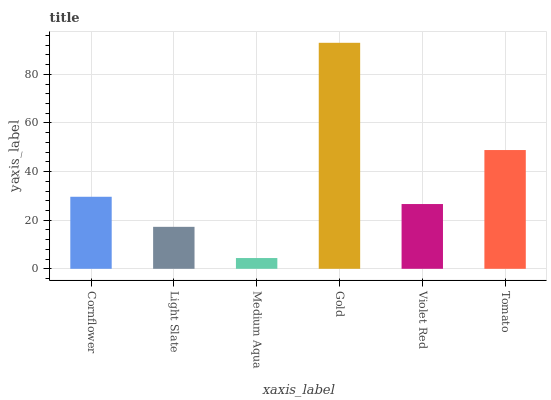Is Medium Aqua the minimum?
Answer yes or no. Yes. Is Gold the maximum?
Answer yes or no. Yes. Is Light Slate the minimum?
Answer yes or no. No. Is Light Slate the maximum?
Answer yes or no. No. Is Cornflower greater than Light Slate?
Answer yes or no. Yes. Is Light Slate less than Cornflower?
Answer yes or no. Yes. Is Light Slate greater than Cornflower?
Answer yes or no. No. Is Cornflower less than Light Slate?
Answer yes or no. No. Is Cornflower the high median?
Answer yes or no. Yes. Is Violet Red the low median?
Answer yes or no. Yes. Is Light Slate the high median?
Answer yes or no. No. Is Light Slate the low median?
Answer yes or no. No. 